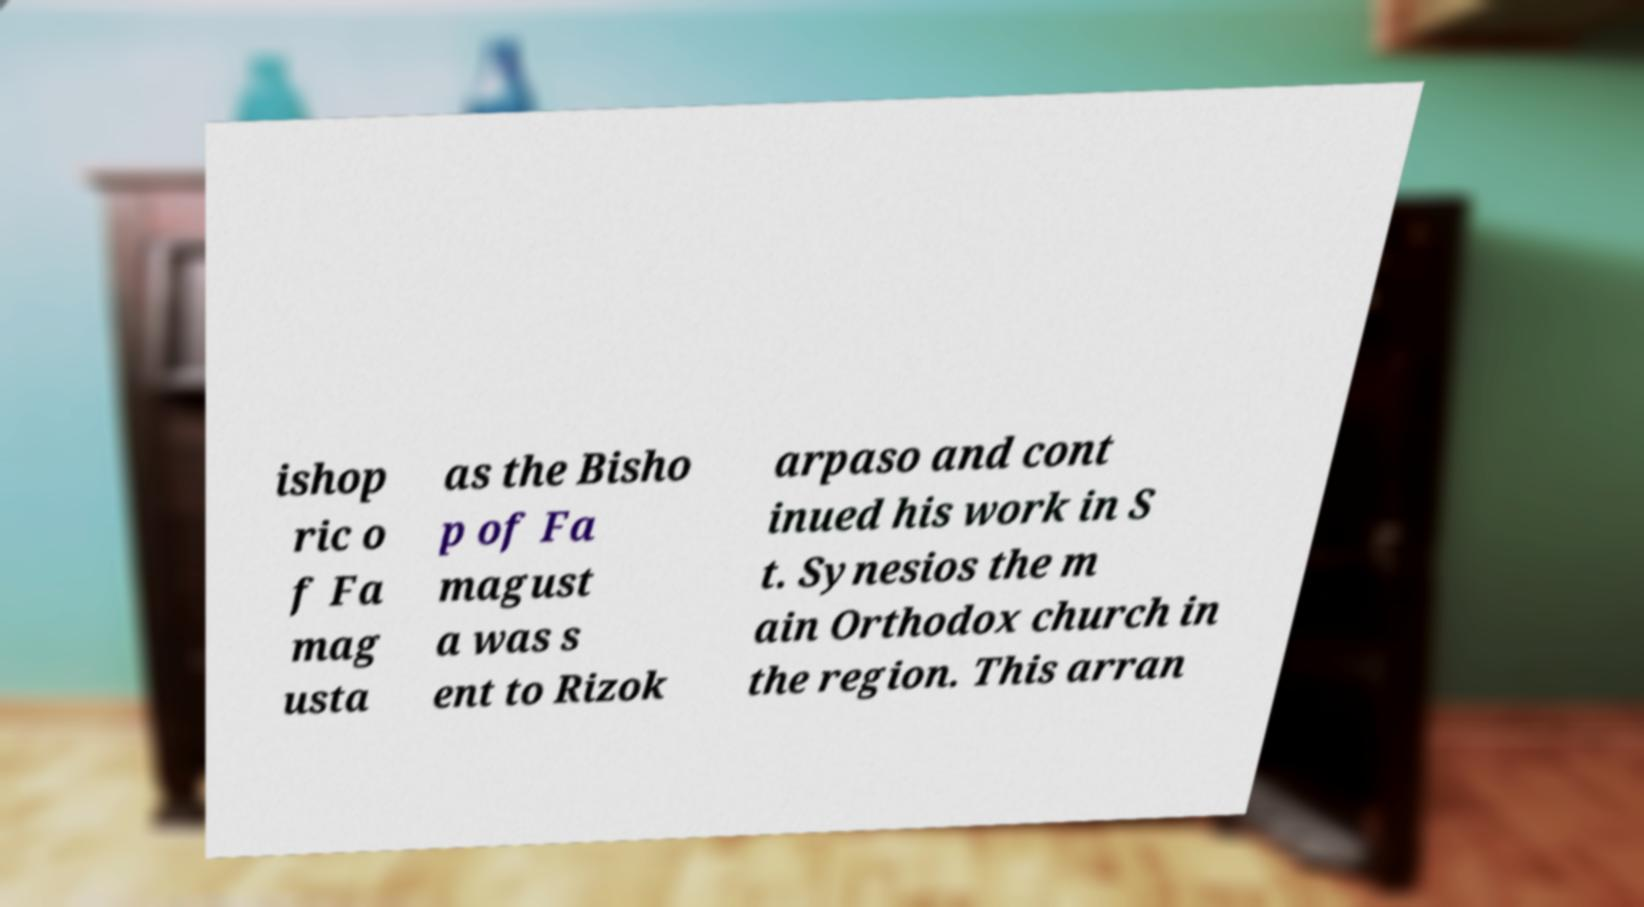Can you read and provide the text displayed in the image?This photo seems to have some interesting text. Can you extract and type it out for me? ishop ric o f Fa mag usta as the Bisho p of Fa magust a was s ent to Rizok arpaso and cont inued his work in S t. Synesios the m ain Orthodox church in the region. This arran 